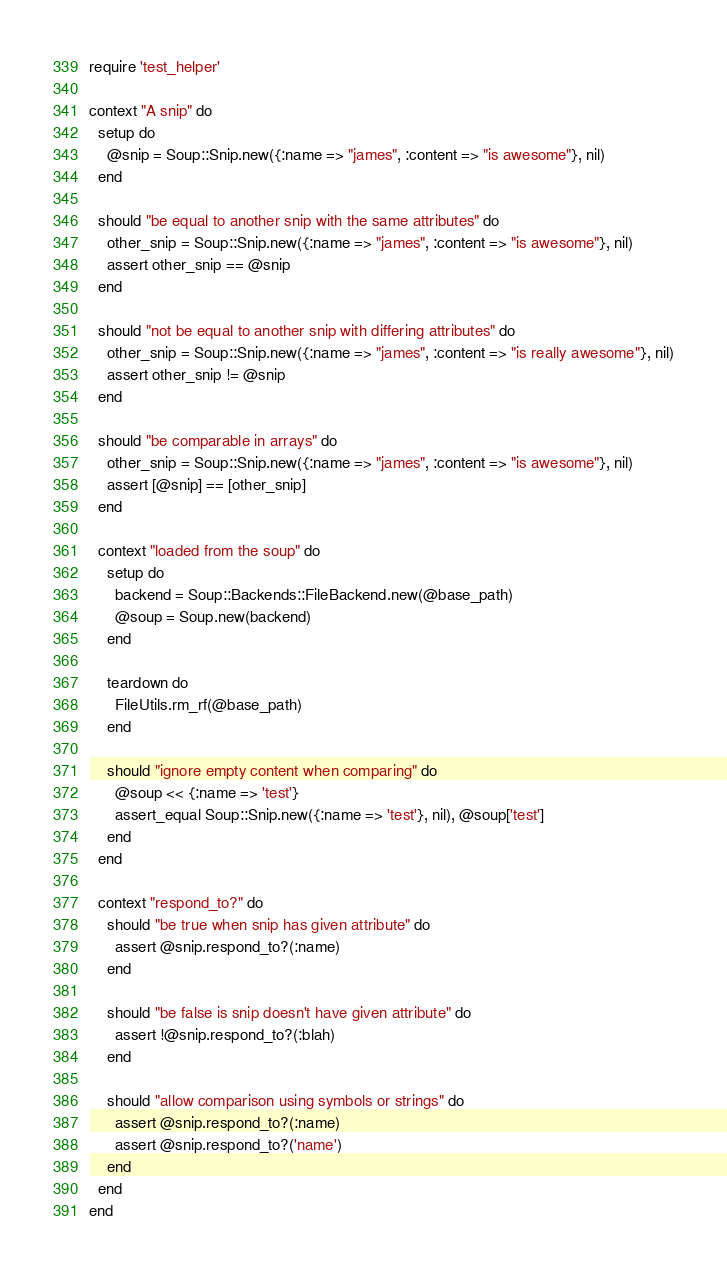<code> <loc_0><loc_0><loc_500><loc_500><_Ruby_>require 'test_helper'

context "A snip" do
  setup do
    @snip = Soup::Snip.new({:name => "james", :content => "is awesome"}, nil)
  end

  should "be equal to another snip with the same attributes" do
    other_snip = Soup::Snip.new({:name => "james", :content => "is awesome"}, nil)
    assert other_snip == @snip
  end

  should "not be equal to another snip with differing attributes" do
    other_snip = Soup::Snip.new({:name => "james", :content => "is really awesome"}, nil)
    assert other_snip != @snip
  end

  should "be comparable in arrays" do
    other_snip = Soup::Snip.new({:name => "james", :content => "is awesome"}, nil)
    assert [@snip] == [other_snip]
  end

  context "loaded from the soup" do
    setup do
      backend = Soup::Backends::FileBackend.new(@base_path)
      @soup = Soup.new(backend)
    end

    teardown do
      FileUtils.rm_rf(@base_path)
    end

    should "ignore empty content when comparing" do
      @soup << {:name => 'test'}
      assert_equal Soup::Snip.new({:name => 'test'}, nil), @soup['test']
    end
  end

  context "respond_to?" do
    should "be true when snip has given attribute" do
      assert @snip.respond_to?(:name)
    end

    should "be false is snip doesn't have given attribute" do
      assert !@snip.respond_to?(:blah)
    end

    should "allow comparison using symbols or strings" do
      assert @snip.respond_to?(:name)
      assert @snip.respond_to?('name')
    end
  end
end
</code> 